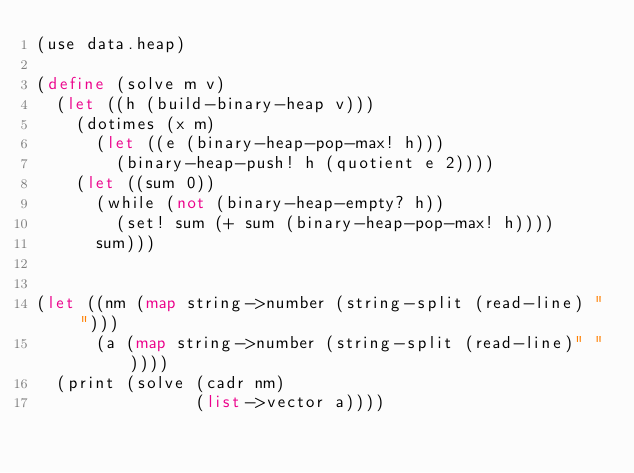Convert code to text. <code><loc_0><loc_0><loc_500><loc_500><_Scheme_>(use data.heap)

(define (solve m v)
  (let ((h (build-binary-heap v)))
    (dotimes (x m)
      (let ((e (binary-heap-pop-max! h)))
        (binary-heap-push! h (quotient e 2))))
    (let ((sum 0))
      (while (not (binary-heap-empty? h))
        (set! sum (+ sum (binary-heap-pop-max! h))))
      sum)))


(let ((nm (map string->number (string-split (read-line) " ")))
      (a (map string->number (string-split (read-line)" "))))
  (print (solve (cadr nm)
                (list->vector a))))
</code> 